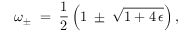<formula> <loc_0><loc_0><loc_500><loc_500>\omega _ { \pm } \, = \, \frac { 1 } { 2 } \left ( 1 \, \pm { } \sqrt { 1 + 4 \, \epsilon } \right ) ,</formula> 